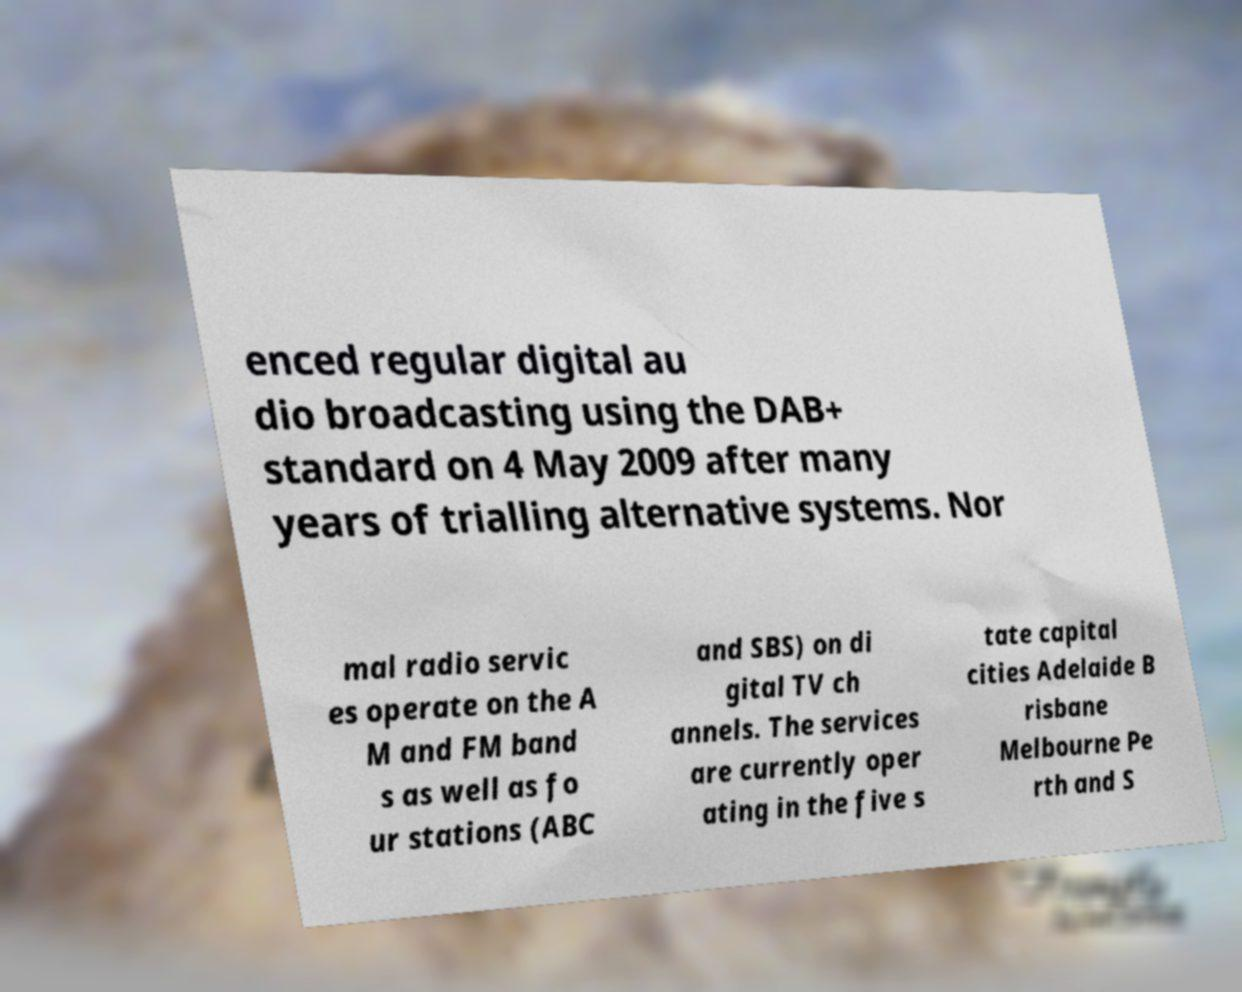Can you read and provide the text displayed in the image?This photo seems to have some interesting text. Can you extract and type it out for me? enced regular digital au dio broadcasting using the DAB+ standard on 4 May 2009 after many years of trialling alternative systems. Nor mal radio servic es operate on the A M and FM band s as well as fo ur stations (ABC and SBS) on di gital TV ch annels. The services are currently oper ating in the five s tate capital cities Adelaide B risbane Melbourne Pe rth and S 